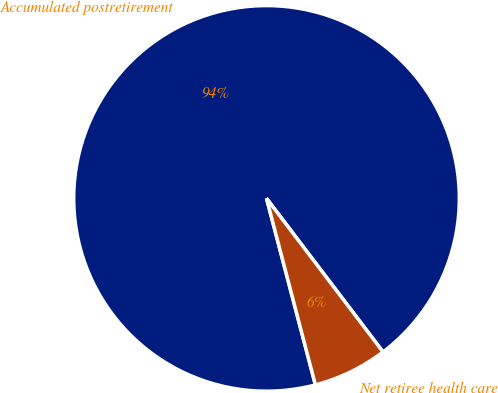Convert chart. <chart><loc_0><loc_0><loc_500><loc_500><pie_chart><fcel>Accumulated postretirement<fcel>Net retiree health care<nl><fcel>93.75%<fcel>6.25%<nl></chart> 